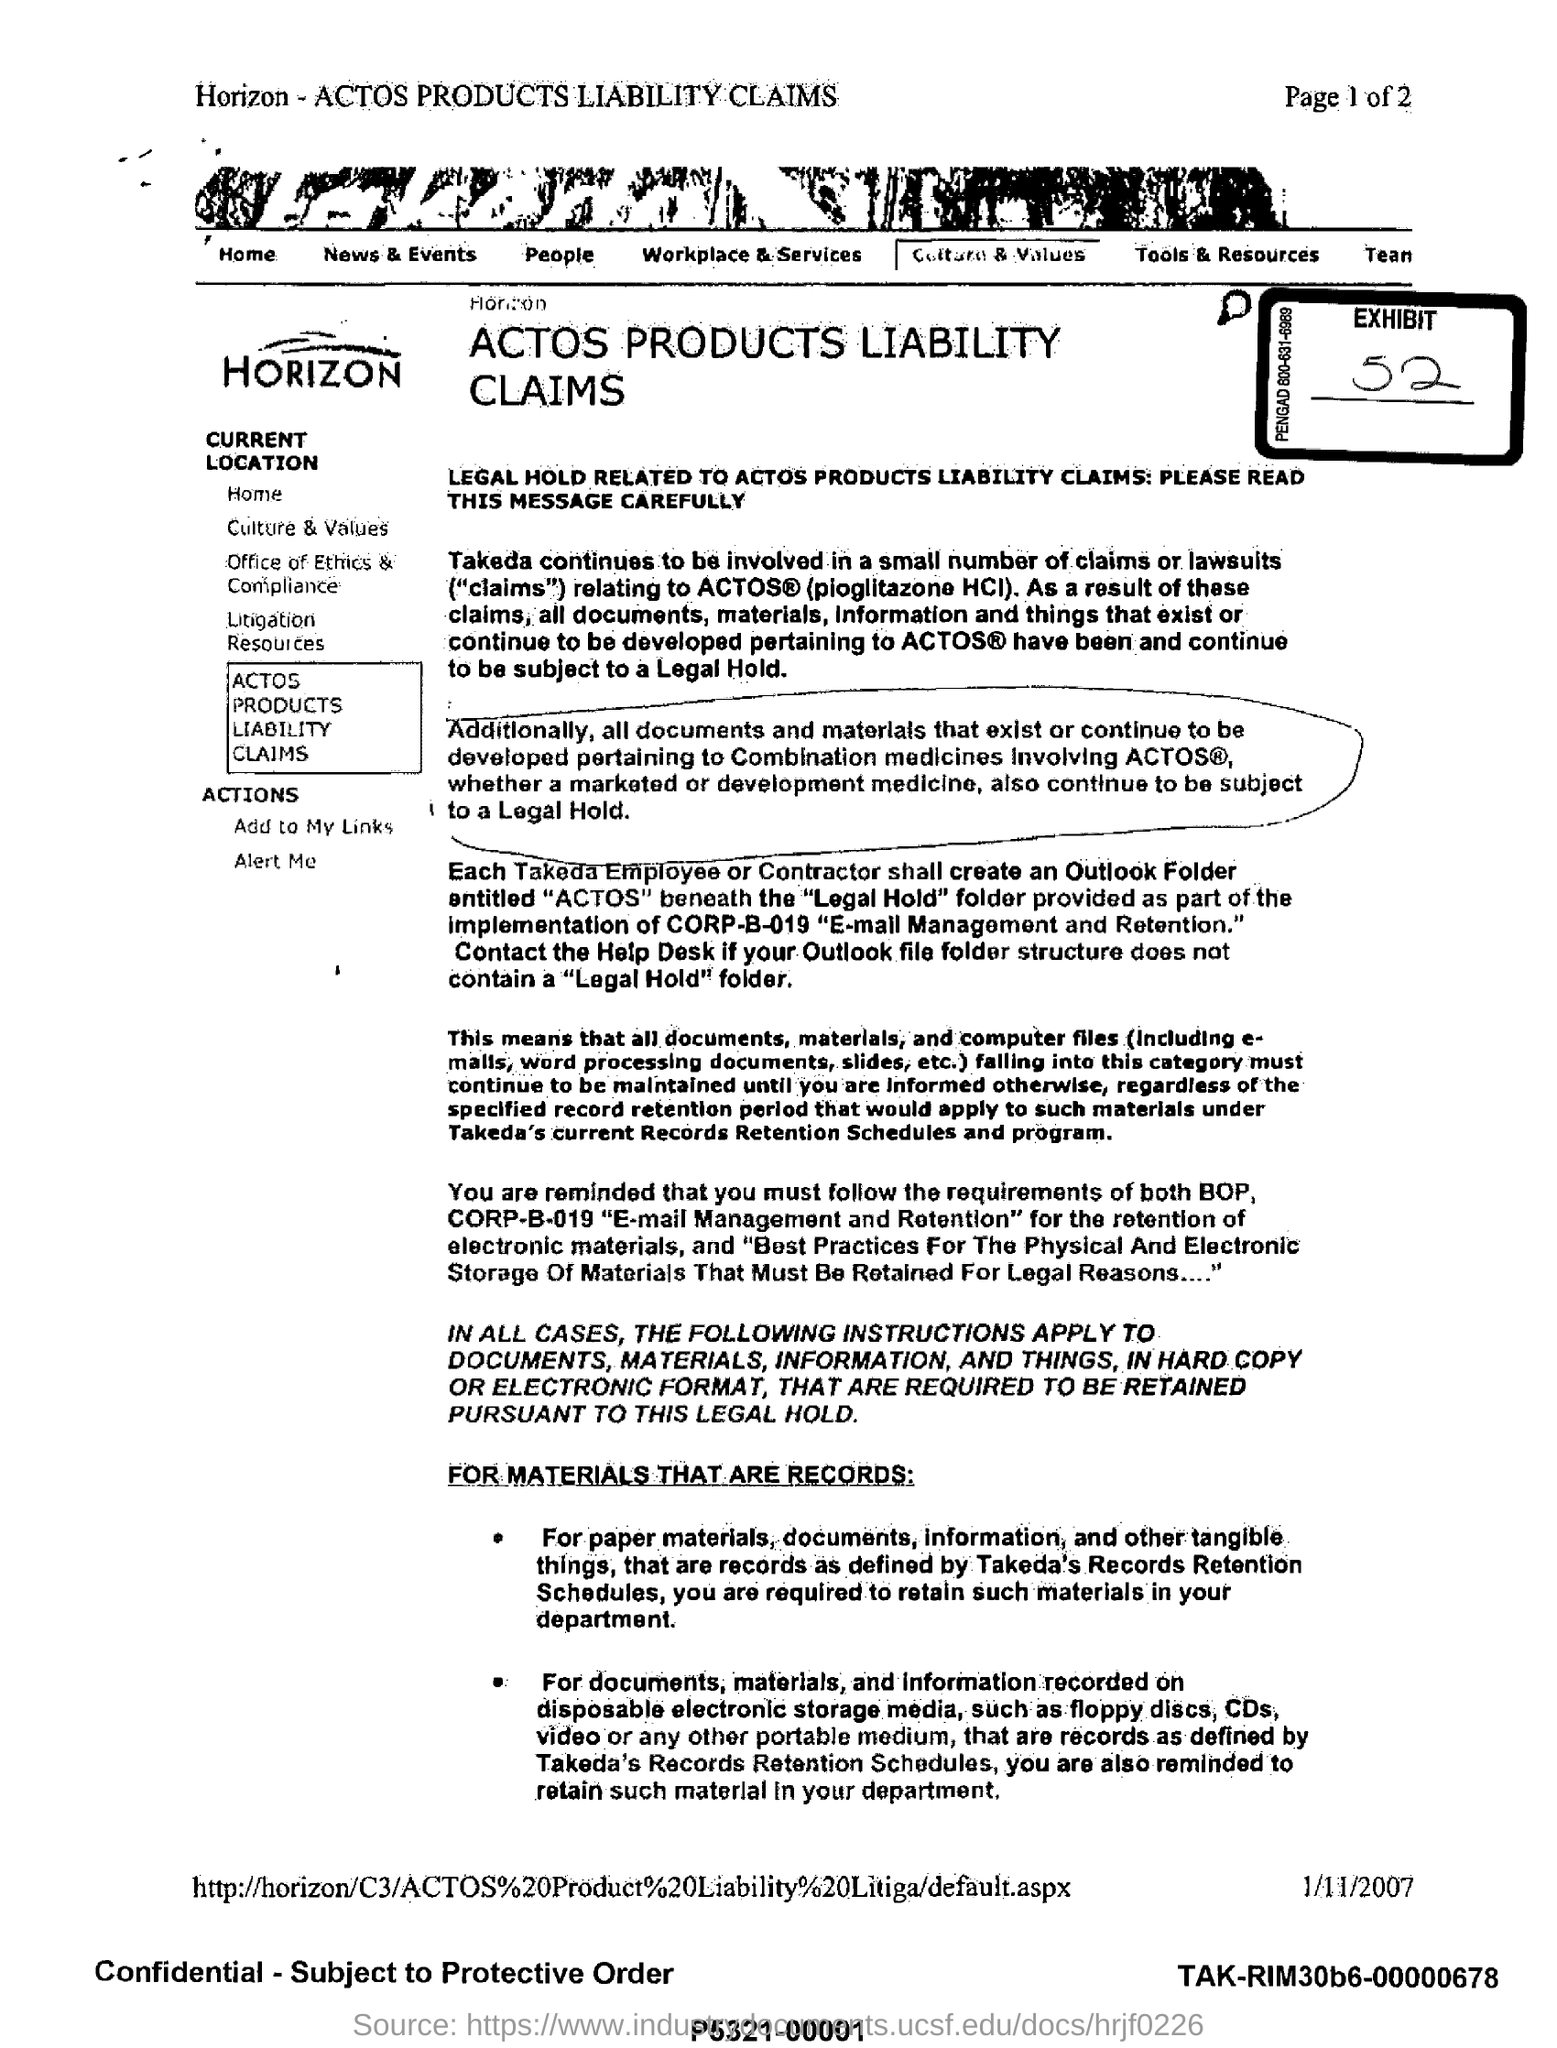Which product's liability claims are described here?
Make the answer very short. ACTOS PRODUCTS. What is the date mentioned in this document at the bottom?
Offer a very short reply. 1/11/2007. What is the exhibit number?
Offer a very short reply. 52. 